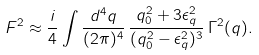Convert formula to latex. <formula><loc_0><loc_0><loc_500><loc_500>F ^ { 2 } \approx \frac { i } { 4 } \int \frac { d ^ { 4 } q } { ( 2 \pi ) ^ { 4 } } \, \frac { q _ { 0 } ^ { 2 } + 3 \epsilon _ { q } ^ { 2 } } { ( q _ { 0 } ^ { 2 } - \epsilon _ { q } ^ { 2 } ) ^ { 3 } } \, \Gamma ^ { 2 } ( q ) .</formula> 